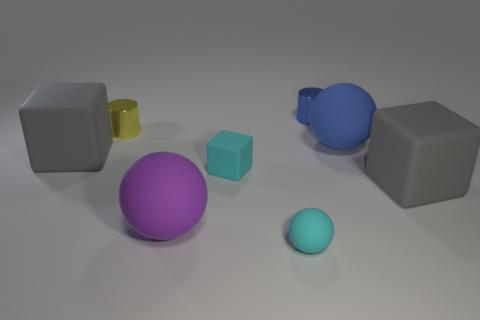Add 2 matte blocks. How many objects exist? 10 Subtract all cubes. How many objects are left? 5 Subtract 0 gray spheres. How many objects are left? 8 Subtract all yellow cylinders. Subtract all large blue objects. How many objects are left? 6 Add 7 cyan things. How many cyan things are left? 9 Add 6 large yellow rubber balls. How many large yellow rubber balls exist? 6 